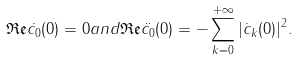Convert formula to latex. <formula><loc_0><loc_0><loc_500><loc_500>\mathfrak { R e } \dot { c _ { 0 } } ( 0 ) = 0 a n d \mathfrak { R e } \ddot { c _ { 0 } } ( 0 ) = - \sum _ { k = 0 } ^ { + \infty } | \dot { c } _ { k } ( 0 ) | ^ { 2 } .</formula> 